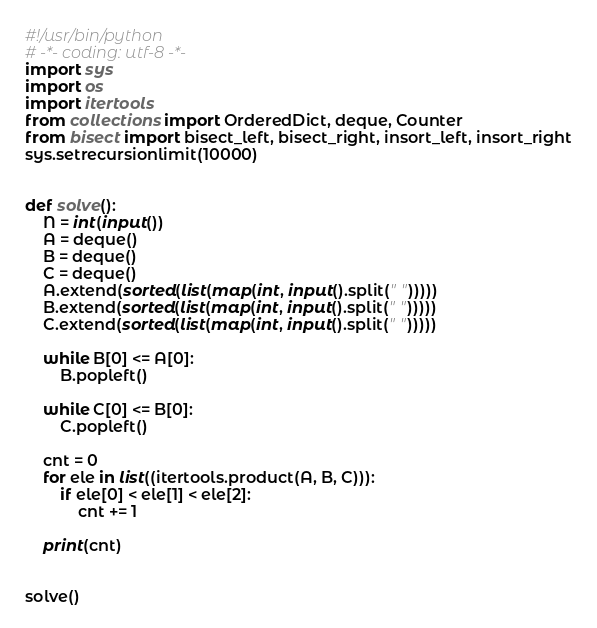<code> <loc_0><loc_0><loc_500><loc_500><_Python_>#!/usr/bin/python
# -*- coding: utf-8 -*-
import sys
import os
import itertools
from collections import OrderedDict, deque, Counter
from bisect import bisect_left, bisect_right, insort_left, insort_right
sys.setrecursionlimit(10000)


def solve():
    N = int(input())
    A = deque()
    B = deque()
    C = deque()
    A.extend(sorted(list(map(int, input().split(" ")))))
    B.extend(sorted(list(map(int, input().split(" ")))))
    C.extend(sorted(list(map(int, input().split(" ")))))

    while B[0] <= A[0]:
        B.popleft()

    while C[0] <= B[0]:
        C.popleft()

    cnt = 0
    for ele in list((itertools.product(A, B, C))):
        if ele[0] < ele[1] < ele[2]:
            cnt += 1

    print(cnt)
    
    
solve()</code> 